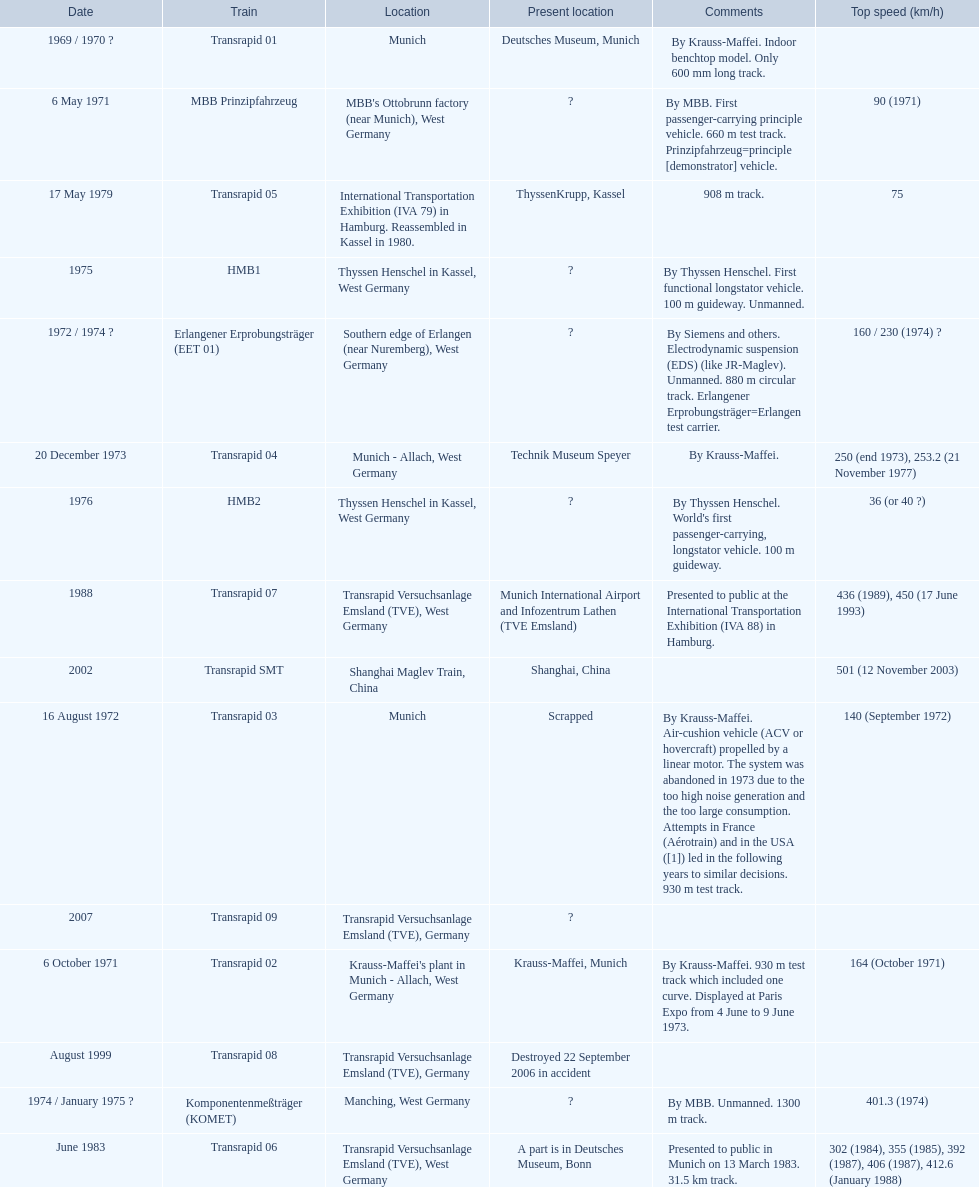What are all of the transrapid trains? Transrapid 01, Transrapid 02, Transrapid 03, Transrapid 04, Transrapid 05, Transrapid 06, Transrapid 07, Transrapid 08, Transrapid SMT, Transrapid 09. Of those, which train had to be scrapped? Transrapid 03. 